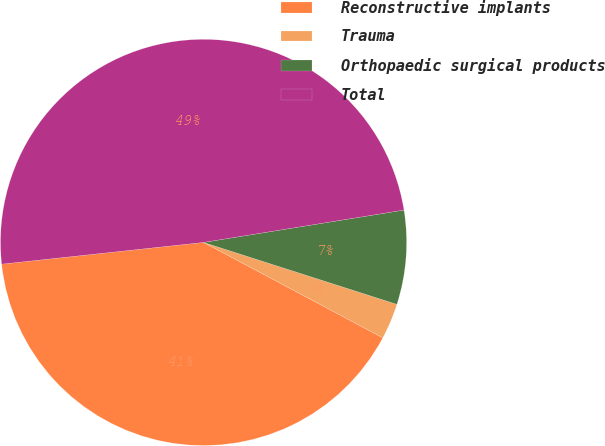<chart> <loc_0><loc_0><loc_500><loc_500><pie_chart><fcel>Reconstructive implants<fcel>Trauma<fcel>Orthopaedic surgical products<fcel>Total<nl><fcel>40.51%<fcel>2.85%<fcel>7.48%<fcel>49.16%<nl></chart> 